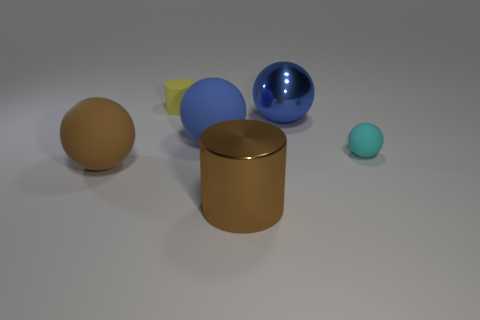How many blocks are either purple things or cyan objects?
Your answer should be compact. 0. Are there more objects right of the small yellow cylinder than yellow rubber cylinders that are on the left side of the big blue metallic thing?
Give a very brief answer. Yes. What number of rubber spheres are the same color as the metallic ball?
Provide a short and direct response. 1. There is a cyan sphere that is the same material as the yellow cylinder; what is its size?
Give a very brief answer. Small. What number of objects are rubber spheres that are in front of the big blue matte sphere or blue balls?
Make the answer very short. 4. Is the color of the large ball to the left of the blue rubber ball the same as the metal cylinder?
Your answer should be compact. Yes. What is the size of the cyan rubber object that is the same shape as the blue matte thing?
Ensure brevity in your answer.  Small. There is a big metal object that is behind the blue object that is in front of the large shiny sphere behind the big cylinder; what color is it?
Your answer should be compact. Blue. Are the tiny cyan thing and the brown cylinder made of the same material?
Your answer should be compact. No. There is a large rubber sphere that is behind the big rubber ball that is on the left side of the yellow matte object; is there a blue matte object in front of it?
Ensure brevity in your answer.  No. 